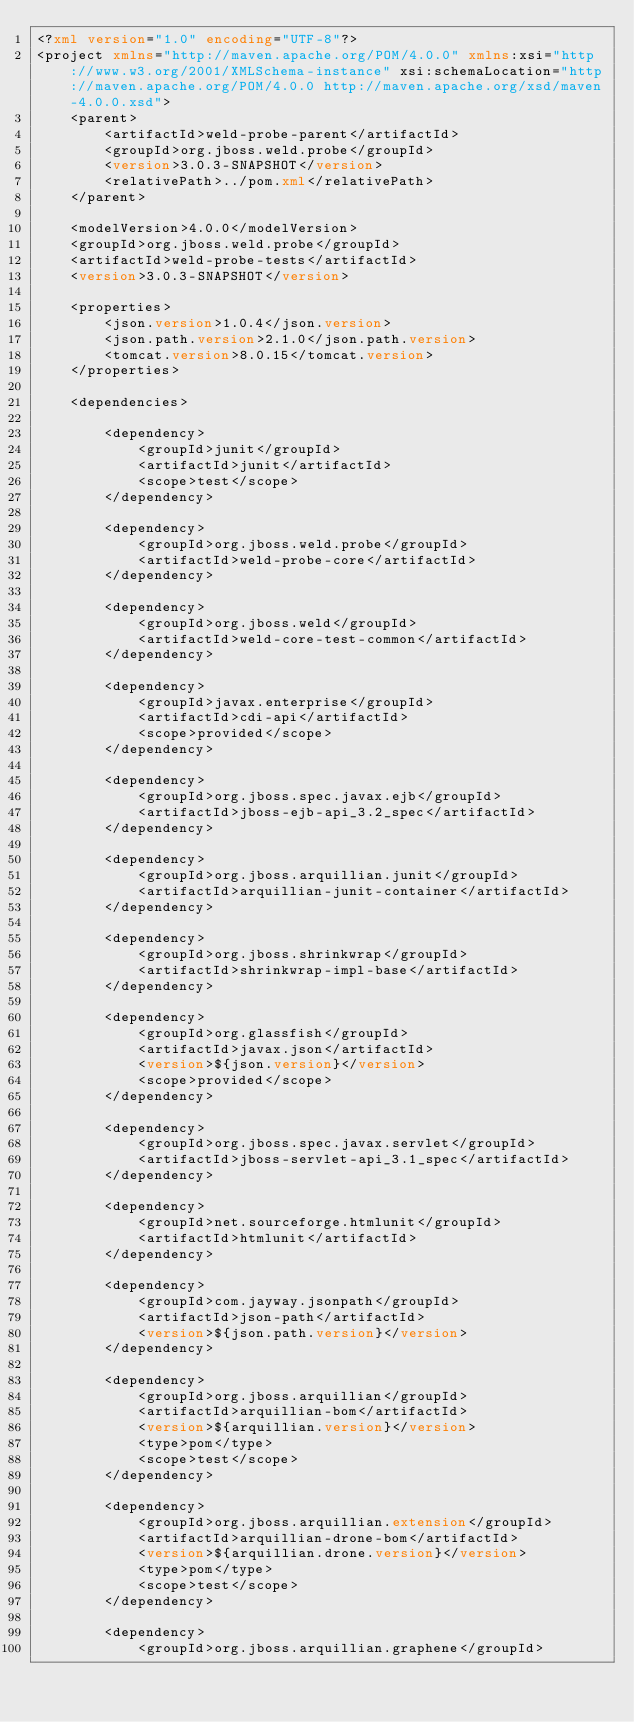<code> <loc_0><loc_0><loc_500><loc_500><_XML_><?xml version="1.0" encoding="UTF-8"?>
<project xmlns="http://maven.apache.org/POM/4.0.0" xmlns:xsi="http://www.w3.org/2001/XMLSchema-instance" xsi:schemaLocation="http://maven.apache.org/POM/4.0.0 http://maven.apache.org/xsd/maven-4.0.0.xsd">
    <parent>
        <artifactId>weld-probe-parent</artifactId>
        <groupId>org.jboss.weld.probe</groupId>
        <version>3.0.3-SNAPSHOT</version>
        <relativePath>../pom.xml</relativePath>
    </parent>

    <modelVersion>4.0.0</modelVersion>
    <groupId>org.jboss.weld.probe</groupId>
    <artifactId>weld-probe-tests</artifactId>
    <version>3.0.3-SNAPSHOT</version>

    <properties>
        <json.version>1.0.4</json.version>
        <json.path.version>2.1.0</json.path.version>
        <tomcat.version>8.0.15</tomcat.version>
    </properties>

    <dependencies>
        
        <dependency>
            <groupId>junit</groupId>
            <artifactId>junit</artifactId>
            <scope>test</scope>
        </dependency>
        
        <dependency>
            <groupId>org.jboss.weld.probe</groupId>
            <artifactId>weld-probe-core</artifactId>
        </dependency>
        
        <dependency>
            <groupId>org.jboss.weld</groupId>
            <artifactId>weld-core-test-common</artifactId>
        </dependency>
        
        <dependency>
            <groupId>javax.enterprise</groupId>
            <artifactId>cdi-api</artifactId>
            <scope>provided</scope>
        </dependency>
        
        <dependency>
            <groupId>org.jboss.spec.javax.ejb</groupId>
            <artifactId>jboss-ejb-api_3.2_spec</artifactId>
        </dependency>
        
        <dependency>
            <groupId>org.jboss.arquillian.junit</groupId>
            <artifactId>arquillian-junit-container</artifactId>
        </dependency>
        
        <dependency>
            <groupId>org.jboss.shrinkwrap</groupId>
            <artifactId>shrinkwrap-impl-base</artifactId>
        </dependency>
        
        <dependency>
            <groupId>org.glassfish</groupId>
            <artifactId>javax.json</artifactId>
            <version>${json.version}</version>
            <scope>provided</scope>
        </dependency>
        
        <dependency>
            <groupId>org.jboss.spec.javax.servlet</groupId>
            <artifactId>jboss-servlet-api_3.1_spec</artifactId>
        </dependency>
        
        <dependency>
            <groupId>net.sourceforge.htmlunit</groupId>
            <artifactId>htmlunit</artifactId>
        </dependency>

        <dependency>
            <groupId>com.jayway.jsonpath</groupId>
            <artifactId>json-path</artifactId>
            <version>${json.path.version}</version>
        </dependency>
        
        <dependency>
            <groupId>org.jboss.arquillian</groupId>
            <artifactId>arquillian-bom</artifactId>
            <version>${arquillian.version}</version>
            <type>pom</type>
            <scope>test</scope>
        </dependency>

        <dependency>
            <groupId>org.jboss.arquillian.extension</groupId>
            <artifactId>arquillian-drone-bom</artifactId>
            <version>${arquillian.drone.version}</version>
            <type>pom</type>
            <scope>test</scope>
        </dependency>

        <dependency>
            <groupId>org.jboss.arquillian.graphene</groupId></code> 